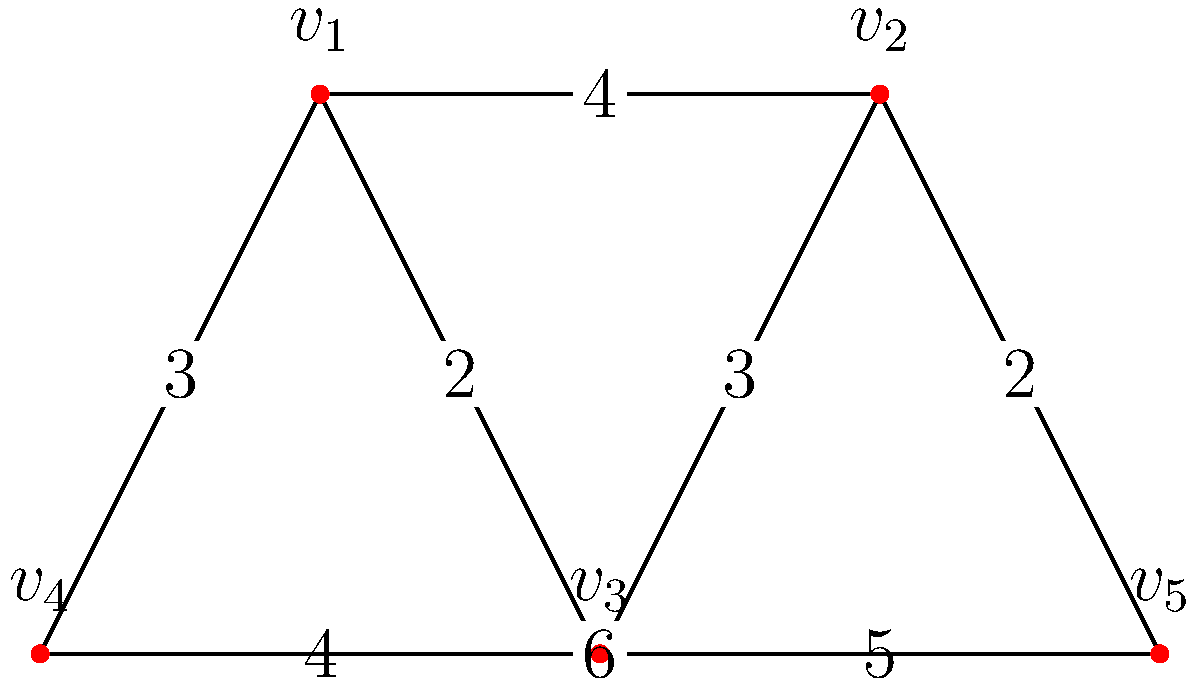Consider the connected, weighted graph depicted above. Using Kruskal's algorithm, determine the weight of the minimum spanning tree. Assume that in case of ties, edges are selected based on the lowest-numbered vertices they connect. Let's apply Kruskal's algorithm step-by-step to find the minimum spanning tree:

1. Sort all edges by weight in ascending order:
   $(v_1, v_3)$ : 2
   $(v_2, v_5)$ : 2
   $(v_1, v_4)$ : 3
   $(v_2, v_3)$ : 3
   $(v_1, v_2)$ : 4
   $(v_3, v_4)$ : 4
   $(v_3, v_5)$ : 5
   $(v_4, v_5)$ : 6

2. Start with an empty set of edges and add edges that don't create cycles:
   - Add $(v_1, v_3)$ : weight 2
   - Add $(v_2, v_5)$ : weight 2
   - Add $(v_1, v_4)$ : weight 3
   - Add $(v_2, v_3)$ : weight 3

3. At this point, we have added 4 edges, which is sufficient for a minimum spanning tree in a graph with 5 vertices.

4. The total weight of the minimum spanning tree is:
   $2 + 2 + 3 + 3 = 10$

Therefore, the weight of the minimum spanning tree is 10.
Answer: 10 